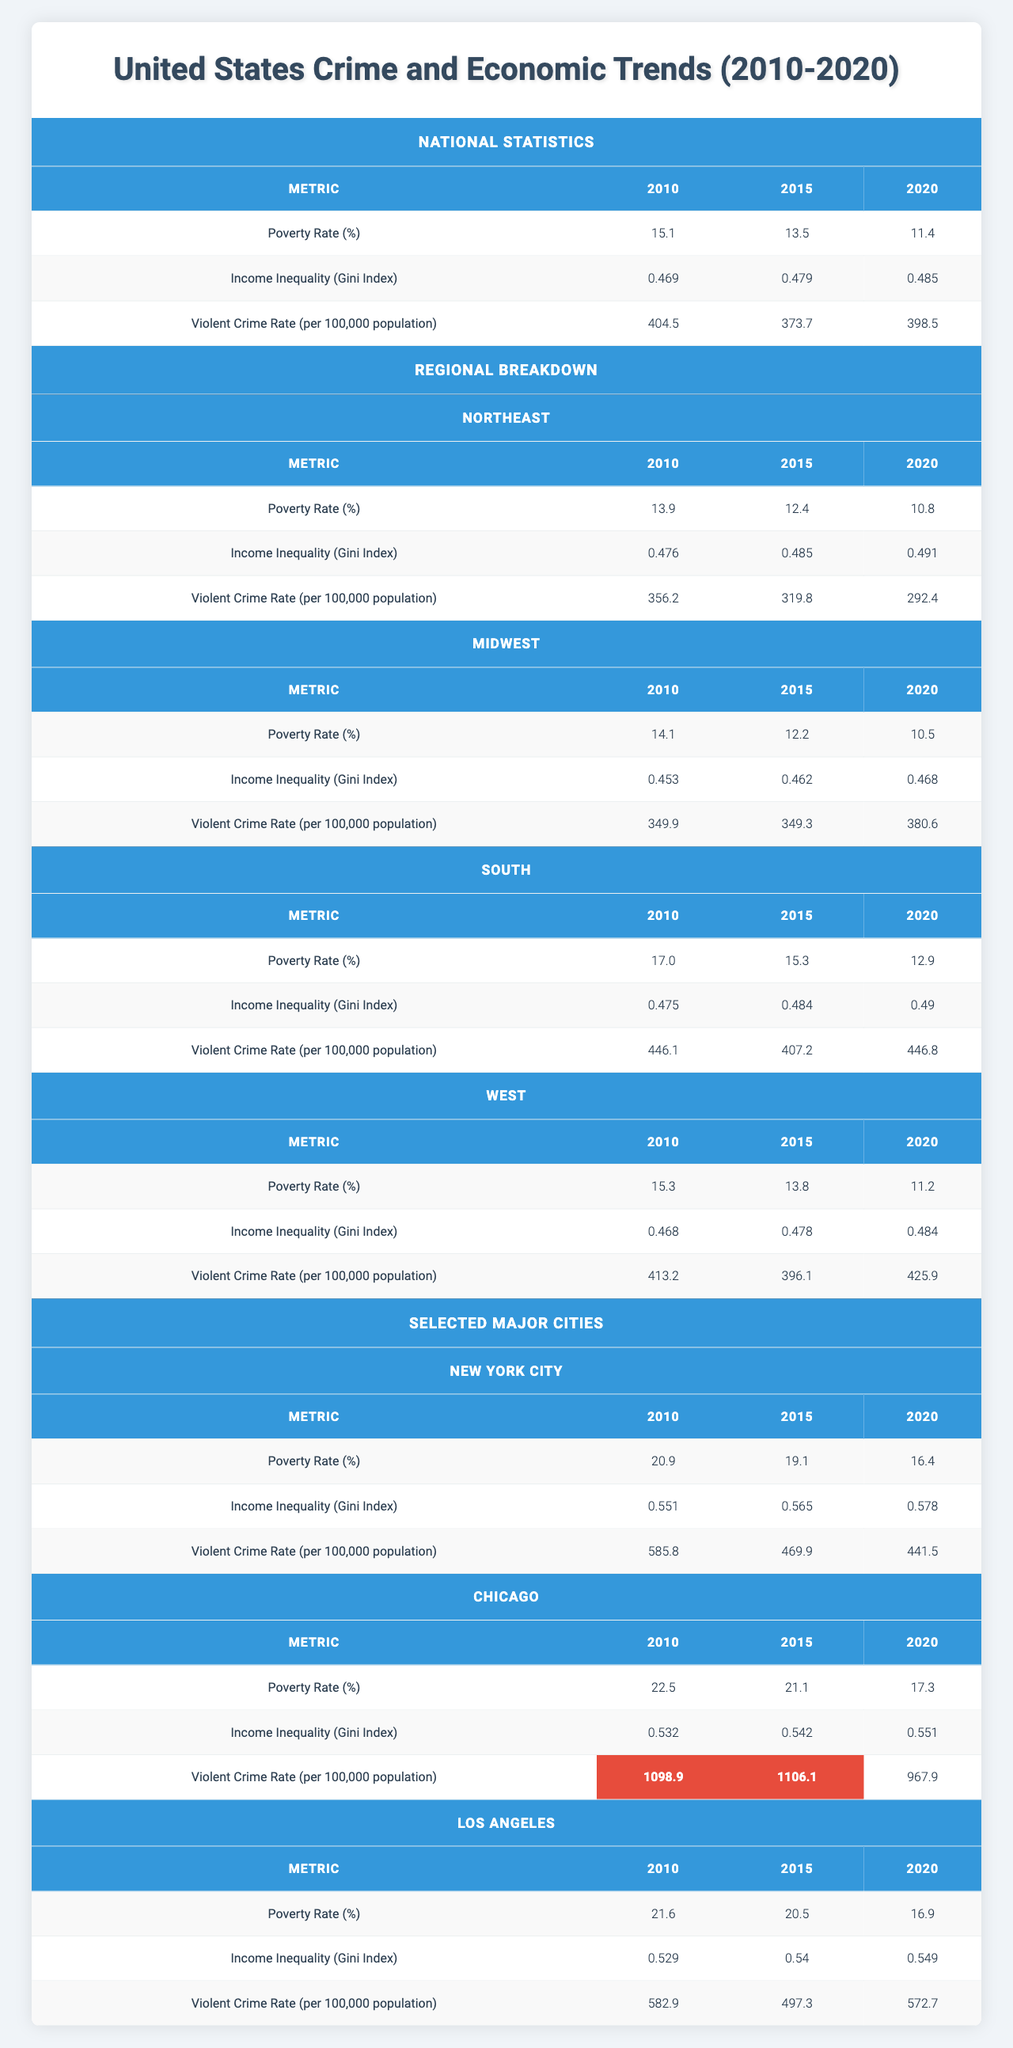What was the poverty rate in the United States in 2015? The table shows the national statistics under "Poverty Rate (%)" for 2015, which is listed as 13.5%.
Answer: 13.5% Which region had the highest poverty rate in 2010? By comparing the poverty rates for each region in 2010, the South had the highest rate at 17.0%.
Answer: South In what year did the income inequality (Gini Index) reach its highest value nationally? The table indicates that the highest Gini Index value nationally is 0.485, recorded in 2020.
Answer: 2020 What was the change in violent crime rate from 2015 to 2020 in the Midwest? The violent crime rates in the Midwest are 349.3 in 2015 and 380.6 in 2020. The difference is 380.6 - 349.3 = 31.3.
Answer: 31.3 Which of the four regions had the lowest violent crime rate in 2020? The violent crime rates in 2020 are 292.4 (Northeast), 380.6 (Midwest), 446.8 (South), and 425.9 (West). The Northeast had the lowest at 292.4.
Answer: Northeast What is the average poverty rate across all regions in 2020? The poverty rates in 2020 are: Northeast (10.8), Midwest (10.5), South (12.9), and West (11.2). The total is 10.8 + 10.5 + 12.9 + 11.2 = 45.4. The average is 45.4 / 4 = 11.35.
Answer: 11.35 In 2010, which city had the highest income inequality? The income inequality (Gini Index) in 2010 for the selected cities shows that Chicago had the highest value at 0.532.
Answer: Chicago True or False: The violent crime rate decreased from 2010 to 2015 in Los Angeles. The violent crime rates in Los Angeles were 582.9 in 2010 and 497.3 in 2015, which indicates a decrease.
Answer: True How did the poverty rate change in New York City from 2010 to 2020? The poverty rate in New York City decreased from 20.9% in 2010 to 16.4% in 2020. The change is 20.9 - 16.4 = 4.5%.
Answer: 4.5% Which city experienced the smallest decrease in violent crime rate between 2015 and 2020? The violent crime rates are: New York City (469.9 in 2015, 441.5 in 2020), Chicago (1106.1 in 2015, 967.9 in 2020), and Los Angeles (497.3 in 2015, 572.7 in 2020). New York City's decrease of 28.4 is the smallest.
Answer: New York City 